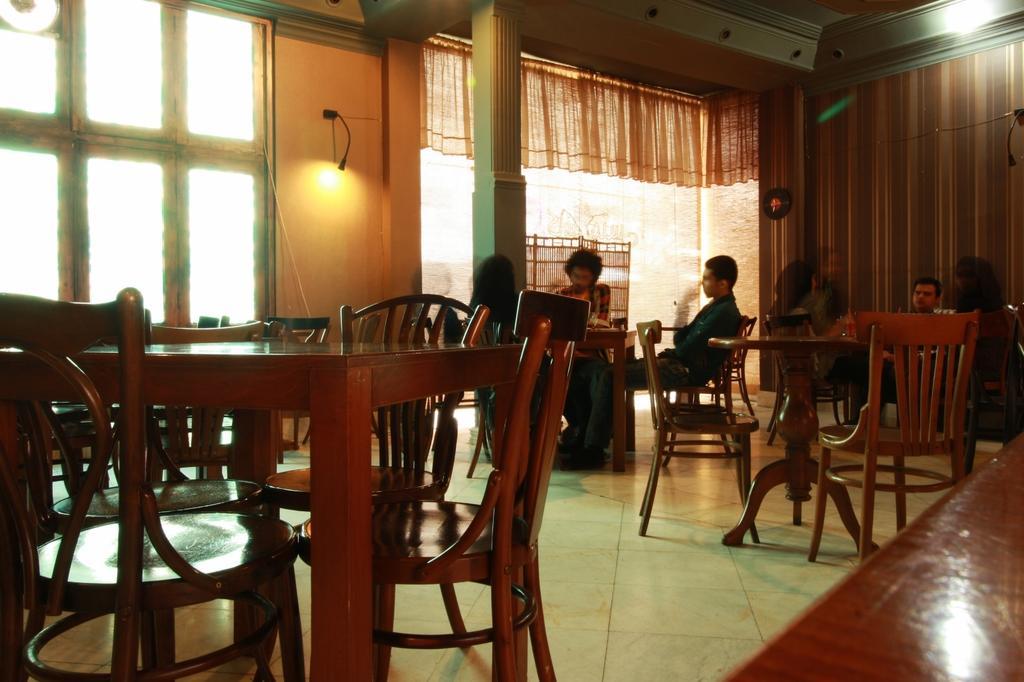Could you give a brief overview of what you see in this image? This is the picture of a place where we have some chairs and tables and some people sitting on the chairs and also we have a light,window and a curtain. 